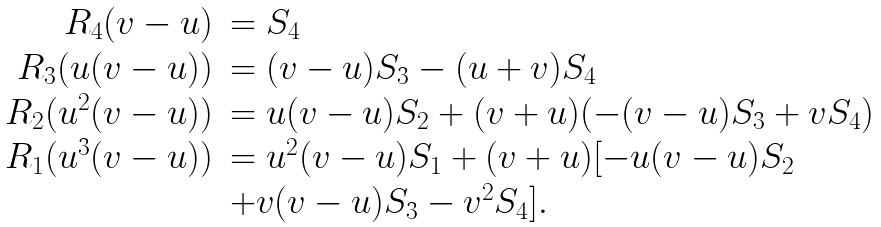<formula> <loc_0><loc_0><loc_500><loc_500>\begin{array} { r l } R _ { 4 } ( v - u ) & = S _ { 4 } \\ R _ { 3 } ( u ( v - u ) ) & = ( v - u ) S _ { 3 } - ( u + v ) S _ { 4 } \\ R _ { 2 } ( u ^ { 2 } ( v - u ) ) & = u ( v - u ) S _ { 2 } + ( v + u ) ( - ( v - u ) S _ { 3 } + v S _ { 4 } ) \\ R _ { 1 } ( u ^ { 3 } ( v - u ) ) & = u ^ { 2 } ( v - u ) S _ { 1 } + ( v + u ) [ - u ( v - u ) S _ { 2 } \\ & + v ( v - u ) S _ { 3 } - v ^ { 2 } S _ { 4 } ] . \end{array}</formula> 